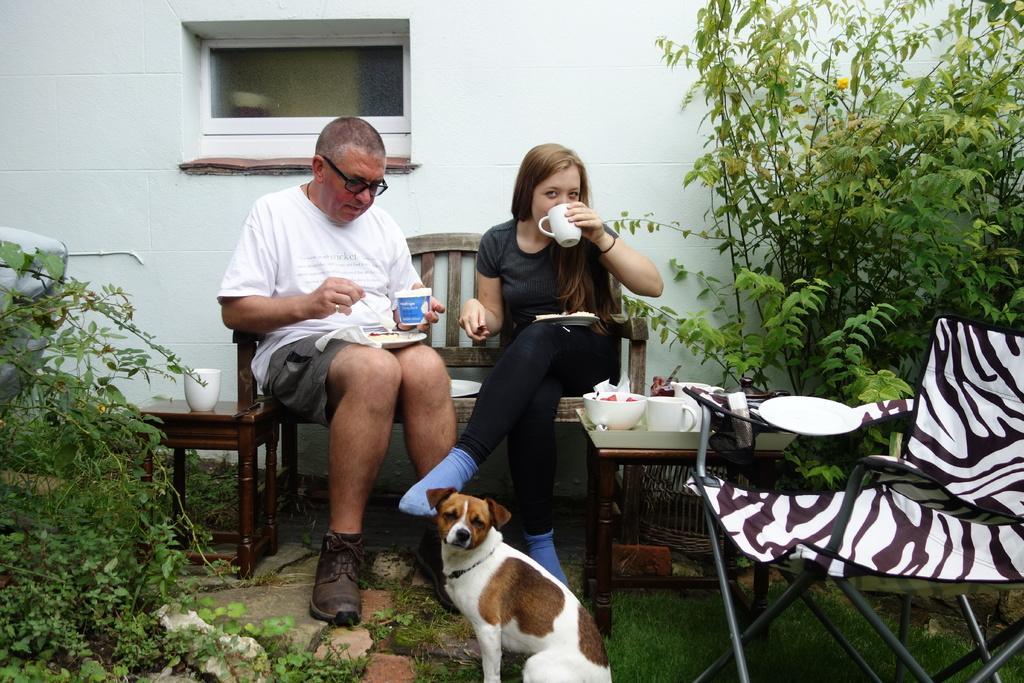Could you give a brief overview of what you see in this image? This image is clicked in a garden. There are two persons in this image. To the left, the man is sitting and wearing a white shirt. To the right, the woman is sitting and wearing a black dress. There is a plant, in the bottom left. In the background, there is a wall and ventilator. To the right, there is a chair. 